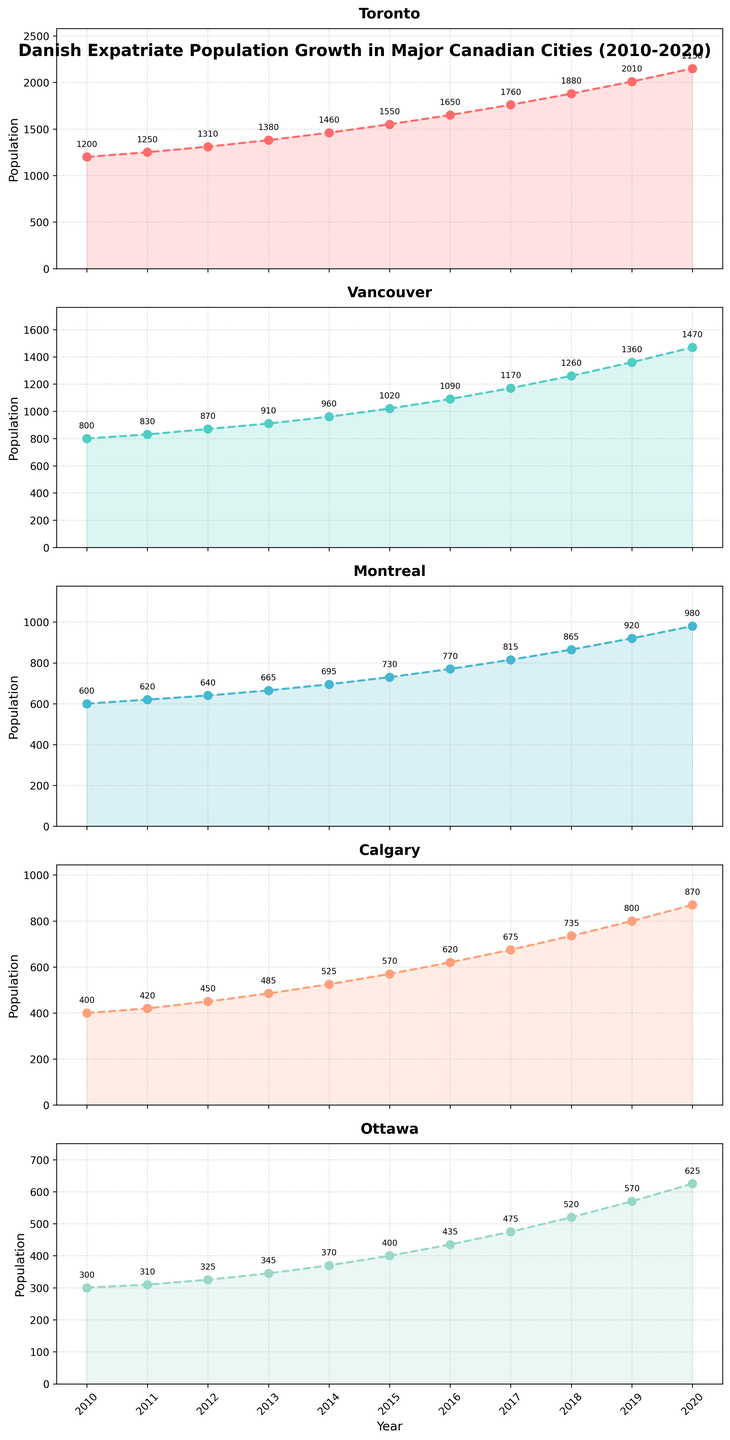What was the population growth in Toronto from 2010 to 2020? To find the population growth in Toronto from 2010 to 2020, subtract the population in 2010 from the population in 2020. The population in 2010 was 1200, and in 2020 it was 2150. The difference is 2150 - 1200 = 950.
Answer: 950 Which city had the highest Danish expatriate population in 2020? To determine which city had the highest population in 2020, look at the population numbers for each city in 2020. Toronto had 2150, Vancouver had 1470, Montreal had 980, Calgary had 870, and Ottawa had 625. Toronto had the highest population with 2150.
Answer: Toronto What is the average population of Danish expatriates in Vancouver from 2010 to 2020? To find the average population of Danish expatriates in Vancouver over the given period, first sum the population from 2010 to 2020 and then divide by the number of years. The sum is 800 + 830 + 870 + 910 + 960 + 1020 + 1090 + 1170 + 1260 + 1360 + 1470 = 12140. Dividing by 11 years gives 12140 / 11 ≈ 1103.64.
Answer: 1103.64 In which year did Montreal's Danish expatriate population exceed 800 for the first time? To determine the first year Montreal's population exceeded 800, check the yearly population values for Montreal. In 2017, the population was 815, which is the first year it exceeded 800.
Answer: 2017 Which city showed the greatest increase in Danish expatriate population between 2018 and 2019? To find the city with the greatest increase from 2018 to 2019, calculate the population difference for each city. For Toronto, the increase was 2010 - 1880 = 130. For Vancouver, it was 1360 - 1260 = 100. For Montreal, it was 920 - 865 = 55. For Calgary, it was 800 - 735 = 65. For Ottawa, it was 570 - 520 = 50. Toronto had the greatest increase with 130.
Answer: Toronto What was the percentage increase in Calgary's population from 2010 to 2020? To find the percentage increase, use the formula: ((New Population - Old Population) / Old Population) * 100. For Calgary, ((870 - 400) / 400) * 100 = 117.5%.
Answer: 117.5% Which city had the smallest Danish expatriate population in 2015? To find the city with the smallest population in 2015, compare the values for that year. Toronto had 1550, Vancouver had 1020, Montreal had 730, Calgary had 570, and Ottawa had 400. Ottawa had the smallest population with 400.
Answer: Ottawa Which two cities had a similar population growth pattern over the decade? To identify cities with similar growth patterns, examine the trend lines. Montreal and Calgary both show a steady and relatively parallel increase over the decade, indicating similar growth patterns.
Answer: Montreal and Calgary What was the combined Danish expatriate population of Montreal and Ottawa in 2019? To find the combined population, sum the population of both cities in 2019. For Montreal, the population was 920 and for Ottawa, it was 570. Adding them together gives 920 + 570 = 1490.
Answer: 1490 In which city did the Danish expatriate population double the earliest within the timeframe? To find the city where the population doubled earliest, compare the yearly data for each city. Toronto's population doubled from 1200 in 2010 to 2400 in 2022. Vancouver's population doubled from 800 in 2010 to 1600 in 2019. Montreal's population doubled from 600 in 2010 to 1200 in 2028. Calgary's population doubled from 400 in 2010 to 800 in 2019. Ottawa's population doubled from 300 in 2010 to 600 in 2022. Vancouver and Calgary both reached the doubling point in 2019, but Calgary's difference is larger compared to the base year, making it more significant.
Answer: Calgary 